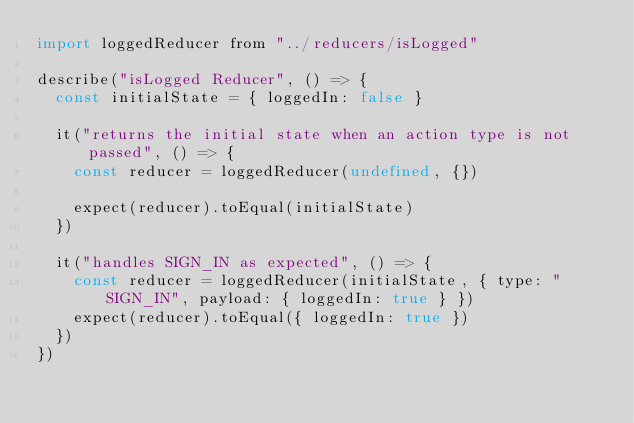Convert code to text. <code><loc_0><loc_0><loc_500><loc_500><_JavaScript_>import loggedReducer from "../reducers/isLogged"

describe("isLogged Reducer", () => {
  const initialState = { loggedIn: false }

  it("returns the initial state when an action type is not passed", () => {
    const reducer = loggedReducer(undefined, {})

    expect(reducer).toEqual(initialState)
  })

  it("handles SIGN_IN as expected", () => {
    const reducer = loggedReducer(initialState, { type: "SIGN_IN", payload: { loggedIn: true } })
    expect(reducer).toEqual({ loggedIn: true })
  })
})
</code> 